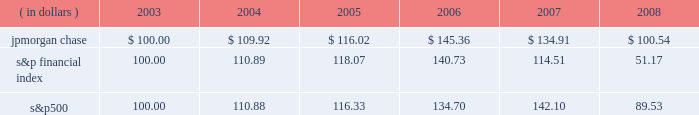Management 2019s discussion and analysis jpmorgan chase & co .
/ 2008 annual report 39 five-year stock performance the table and graph compare the five-year cumulative total return for jpmorgan chase & co .
( 201cjpmorgan chase 201d or the 201cfirm 201d ) common stock with the cumulative return of the s&p 500 stock index and the s&p financial index .
The s&p 500 index is a commonly referenced u.s .
Equity benchmark consisting of leading companies from different economic sectors .
The s&p financial index is an index of 81 financial companies , all of which are within the s&p 500 .
The firm is a component of both industry indices .
The table and graph assumes simultaneous investments of $ 100 on december 31 , 2003 , in jpmorgan chase common stock and in each of the above s&p indices .
The comparison assumes that all dividends are reinvested .
This section of the jpmorgan chase 2019s annual report for the year ended december 31 , 2008 ( 201cannual report 201d ) provides manage- ment 2019s discussion and analysis of the financial condition and results of operations ( 201cmd&a 201d ) of jpmorgan chase .
See the glossary of terms on pages 230 2013233 for definitions of terms used throughout this annual report .
The md&a included in this annual report con- tains statements that are forward-looking within the meaning of the private securities litigation reform act of 1995 .
Such statements are based upon the current beliefs and expectations of jpmorgan december 31 .
December 31 , ( in dollars ) 2003 2004 2005 2006 2007 2008 s&p financial s&p 500jpmorgan chase chase 2019s management and are subject to significant risks and uncer- tainties .
These risks and uncertainties could cause jpmorgan chase 2019s results to differ materially from those set forth in such forward-look- ing statements .
Certain of such risks and uncertainties are described herein ( see forward-looking statements on page 127 of this annual report ) and in the jpmorgan chase annual report on form 10-k for the year ended december 31 , 2008 ( 201c2008 form 10-k 201d ) , in part i , item 1a : risk factors , to which reference is hereby made .
Introduction jpmorgan chase & co. , a financial holding company incorporated under delaware law in 1968 , is a leading global financial services firm and one of the largest banking institutions in the united states of america ( 201cu.s . 201d ) , with $ 2.2 trillion in assets , $ 166.9 billion in stockholders 2019 equity and operations in more than 60 countries as of december 31 , 2008 .
The firm is a leader in investment banking , financial services for consumers and businesses , financial transaction processing and asset management .
Under the j.p .
Morgan and chase brands , the firm serves millions of customers in the u.s .
And many of the world 2019s most prominent corporate , institutional and government clients .
Jpmorgan chase 2019s principal bank subsidiaries are jpmorgan chase bank , national association ( 201cjpmorgan chase bank , n.a . 201d ) , a nation- al banking association with branches in 23 states in the u.s. ; and chase bank usa , national association ( 201cchase bank usa , n.a . 201d ) , a national bank that is the firm 2019s credit card issuing bank .
Jpmorgan chase 2019s principal nonbank subsidiary is j.p .
Morgan securities inc. , the firm 2019s u.s .
Investment banking firm .
Jpmorgan chase 2019s activities are organized , for management reporting purposes , into six business segments , as well as corporate/private equity .
The firm 2019s wholesale businesses comprise the investment bank , commercial banking , treasury & securities services and asset management segments .
The firm 2019s consumer businesses comprise the retail financial services and card services segments .
A description of the firm 2019s business segments , and the products and services they pro- vide to their respective client bases , follows .
Investment bank j.p .
Morgan is one of the world 2019s leading investment banks , with deep client relationships and broad product capabilities .
The investment bank 2019s clients are corporations , financial institutions , governments and institutional investors .
The firm offers a full range of investment banking products and services in all major capital markets , including advising on corporate strategy and structure , cap- ital raising in equity and debt markets , sophisticated risk manage- ment , market-making in cash securities and derivative instruments , prime brokerage and research .
The investment bank ( 201cib 201d ) also selectively commits the firm 2019s own capital to principal investing and trading activities .
Retail financial services retail financial services ( 201crfs 201d ) , which includes the retail banking and consumer lending reporting segments , serves consumers and businesses through personal service at bank branches and through atms , online banking and telephone banking as well as through auto dealerships and school financial aid offices .
Customers can use more than 5400 bank branches ( third-largest nationally ) and 14500 atms ( second-largest nationally ) as well as online and mobile bank- ing around the clock .
More than 21400 branch salespeople assist .
Based on the belief and expectations of the jpmorgan chase expectations what was the ratio of the jpmorgan chase to the s&p financial index performance at december 312008? 
Computations: (100.54 / 51.17)
Answer: 1.96482. 